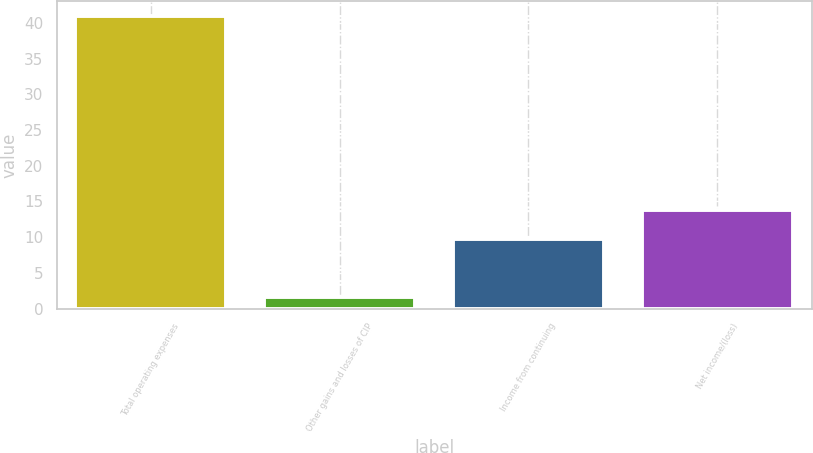Convert chart to OTSL. <chart><loc_0><loc_0><loc_500><loc_500><bar_chart><fcel>Total operating expenses<fcel>Other gains and losses of CIP<fcel>Income from continuing<fcel>Net income/(loss)<nl><fcel>41<fcel>1.6<fcel>9.8<fcel>13.74<nl></chart> 